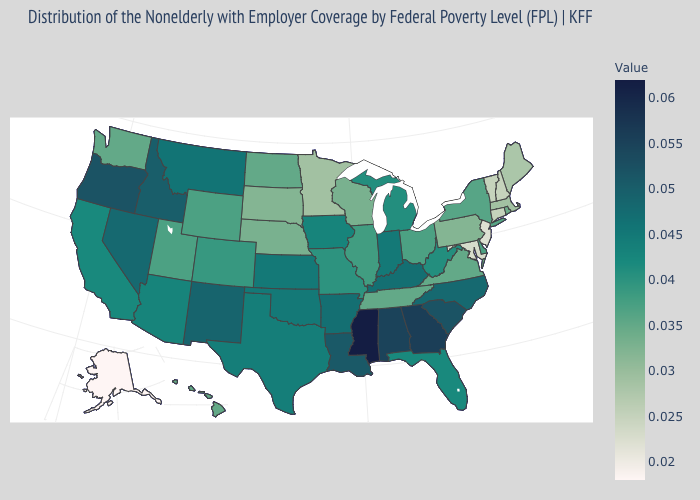Among the states that border Missouri , does Kentucky have the highest value?
Keep it brief. Yes. Does New York have the highest value in the Northeast?
Keep it brief. Yes. Which states have the lowest value in the USA?
Answer briefly. Alaska. Does Kansas have the highest value in the MidWest?
Keep it brief. Yes. Does New Hampshire have a higher value than Kentucky?
Answer briefly. No. Which states have the lowest value in the MidWest?
Answer briefly. Minnesota. Which states have the lowest value in the Northeast?
Answer briefly. New Jersey. 